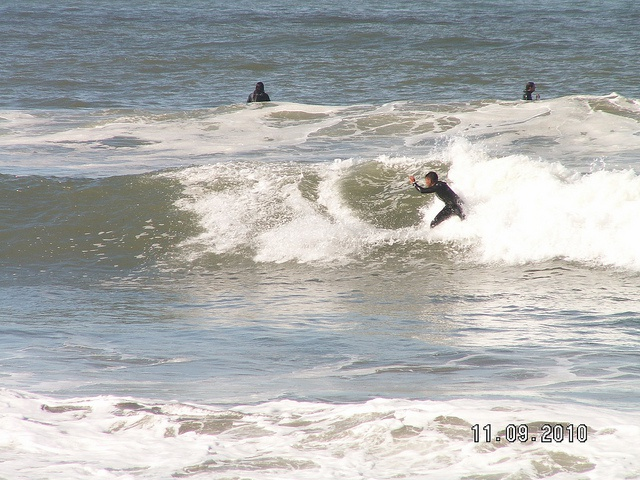Describe the objects in this image and their specific colors. I can see people in gray, black, white, and darkgray tones, people in gray, black, and darkgray tones, and people in gray, black, darkgray, and purple tones in this image. 